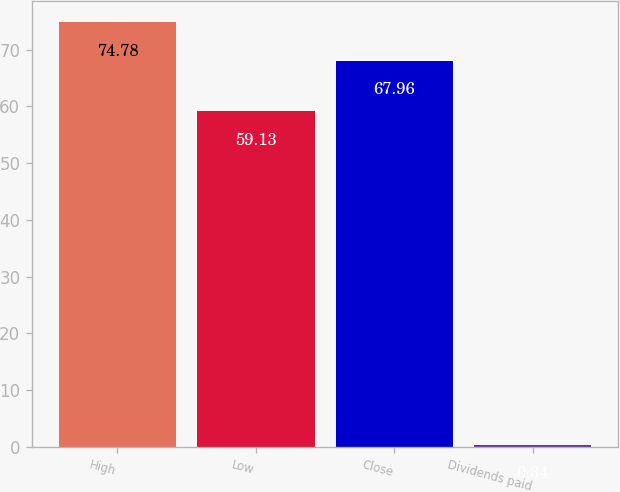Convert chart. <chart><loc_0><loc_0><loc_500><loc_500><bar_chart><fcel>High<fcel>Low<fcel>Close<fcel>Dividends paid<nl><fcel>74.78<fcel>59.13<fcel>67.96<fcel>0.34<nl></chart> 